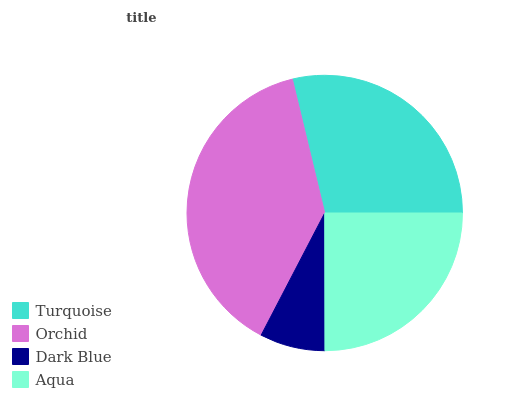Is Dark Blue the minimum?
Answer yes or no. Yes. Is Orchid the maximum?
Answer yes or no. Yes. Is Orchid the minimum?
Answer yes or no. No. Is Dark Blue the maximum?
Answer yes or no. No. Is Orchid greater than Dark Blue?
Answer yes or no. Yes. Is Dark Blue less than Orchid?
Answer yes or no. Yes. Is Dark Blue greater than Orchid?
Answer yes or no. No. Is Orchid less than Dark Blue?
Answer yes or no. No. Is Turquoise the high median?
Answer yes or no. Yes. Is Aqua the low median?
Answer yes or no. Yes. Is Dark Blue the high median?
Answer yes or no. No. Is Turquoise the low median?
Answer yes or no. No. 